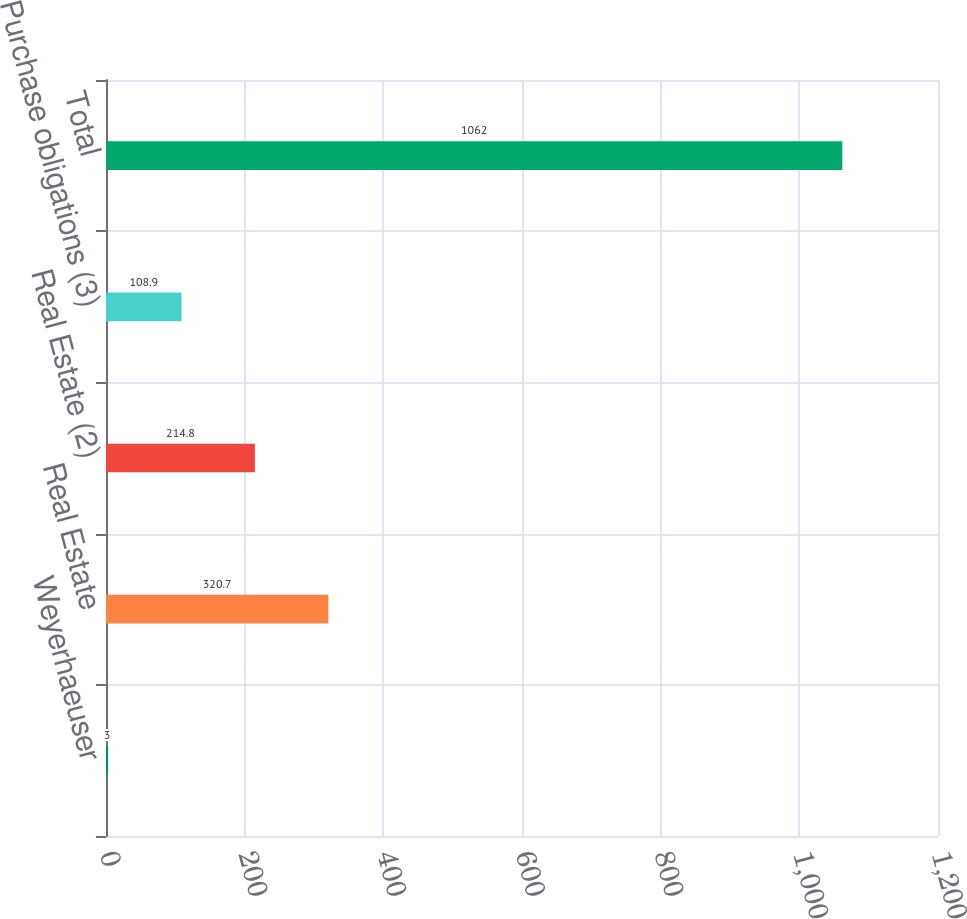Convert chart. <chart><loc_0><loc_0><loc_500><loc_500><bar_chart><fcel>Weyerhaeuser<fcel>Real Estate<fcel>Real Estate (2)<fcel>Purchase obligations (3)<fcel>Total<nl><fcel>3<fcel>320.7<fcel>214.8<fcel>108.9<fcel>1062<nl></chart> 